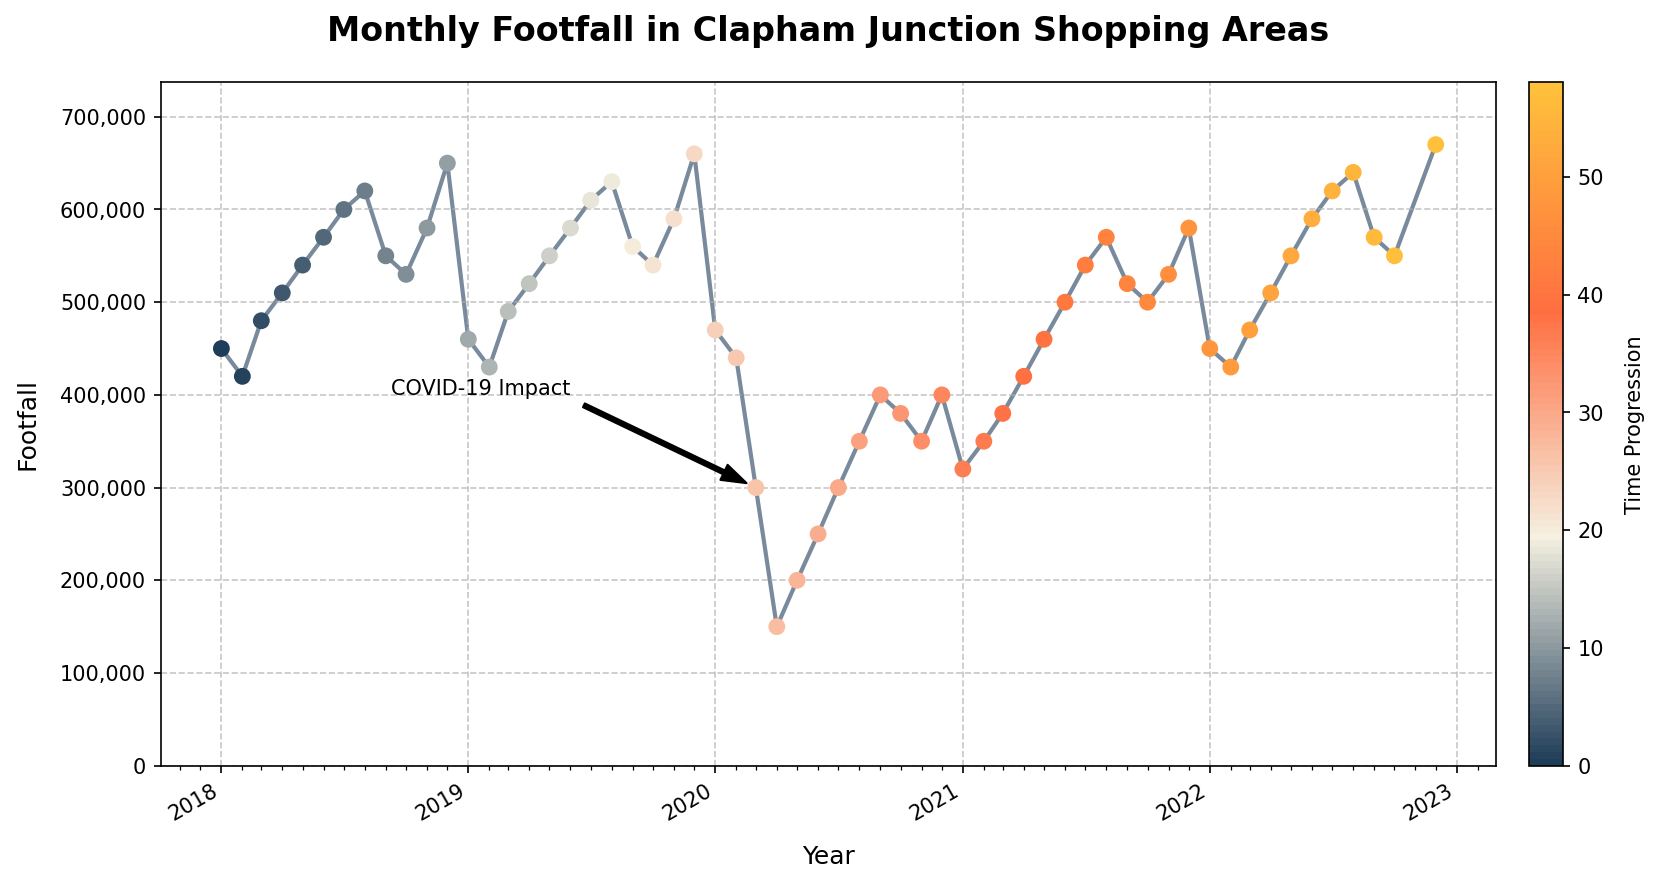What month shows the highest footfall in 2018? By inspecting the chart, we identify each month's footfall in 2018 and find December has the highest peak.
Answer: December Which year had the lowest footfall in March and why? Looking at the footfall line for March across the years, the lowest point is in 2020, which correlates with the COVID-19 impact annotation.
Answer: 2020 What is the total footfall for the year 2020? Sum the monthly footfall values for 2020: 470000 + 440000 + 300000 + 150000 + 200000 + 250000 + 300000 + 350000 + 400000 + 380000 + 350000 + 400000 = 3990000.
Answer: 3,990,000 How did footfall change from July to December in 2021? Inspect the footfall from July (540000) to December (580000) 2021, showing an increase.
Answer: Increased Which month in 2020 had the lowest footfall, and what was the impact? Analyzing the data for 2020, April had the lowest footfall (150000) due to the COVID-19 pandemic.
Answer: April Compare the footfall between August 2019 and August 2020. August 2019 footfall was 630000, while August 2020 was 350000. August 2019 had higher footfall.
Answer: 2019 was higher What can be inferred about the footfall trends around December for the years shown? Observing December across all years, it exhibits peaks, indicating higher footfall likely due to holiday shopping trends.
Answer: Peaks What is the percentage increase in footfall from April 2020 to April 2021? Foothill in April 2020 was 150000, and in April 2021 was 420000. The percentage increase is calculated as ((420000 - 150000) / 150000) * 100 = 180%.
Answer: 180% Identify the overall trend of footfall from 2018 to 2022. The general trend starts high, dips significantly in 2020, then gradually rises again through 2021 and 2022.
Answer: Decrease and then recovery What is the average footfall for the year 2021? Sum the 2021 monthly footfall values and divide by 12: (320000 + 350000 + 380000 + 420000 + 460000 + 500000 + 540000 + 570000 + 520000 + 500000 + 530000 + 580000) / 12 = 4600000 / 12 ≈ 383333.
Answer: 383,333 